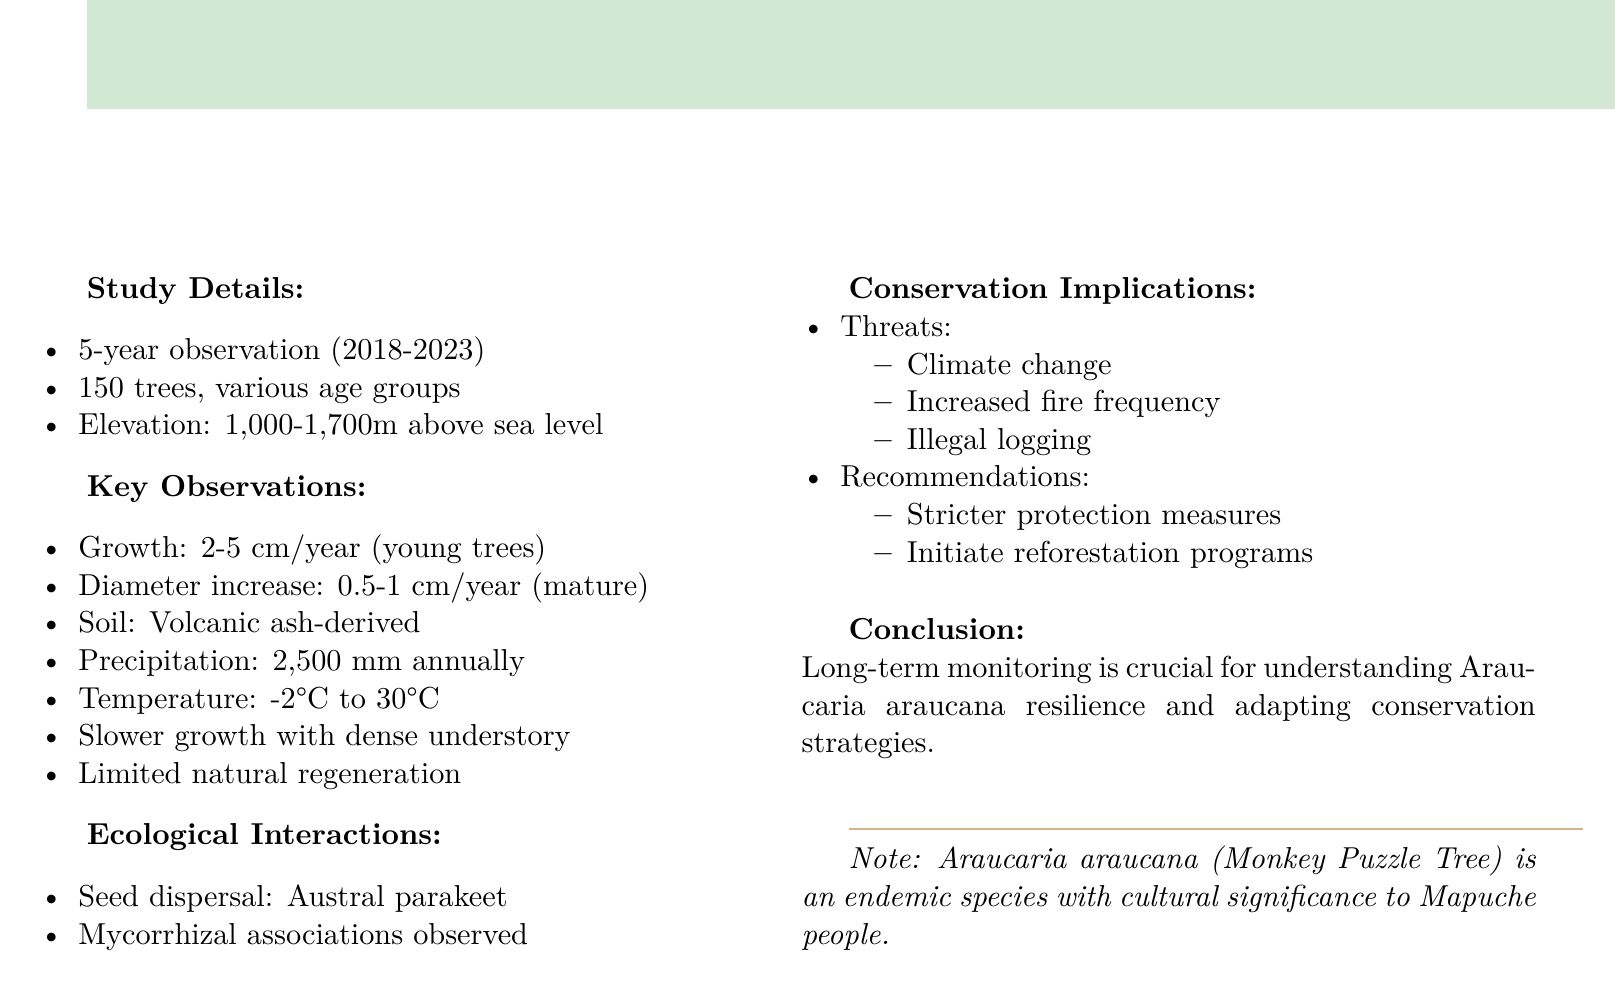What is the species studied in the document? The document focuses on a specific tree species, which is mentioned at the beginning.
Answer: Araucaria araucana What is the duration of the observation period? The observation duration is specified in the study details section of the document.
Answer: 5-year observation period How many trees were included in the study? The sample size is provided in the study details section of the document.
Answer: 150 trees What is the average annual growth for young trees? The document specifies the average annual growth of young trees in the key observations section.
Answer: 2-5 cm What elevation range was studied in Conguillío National Park? The elevation range is stated directly in the study details section.
Answer: 1,000-1,700 meters above sea level What environmental factor affects Araucaria araucana growth? The document notes slower growth in areas with specific environmental competition factors.
Answer: Dense Nothofagus dombeyi understory Which species is responsible for seed dispersal? The document identifies the primary disperser of seeds in the ecological interactions section.
Answer: Austral parakeet What are two main threats to Araucaria araucana discussed in the document? The conservation implications section outlines several threats, but the question asks for two of them.
Answer: Climate change, Illegal logging What do the recommendations emphasize for Araucaria araucana? The document provides recommendations in the conservation implications section that focus on specific actions.
Answer: Stricter protection measures, reforestation programs 